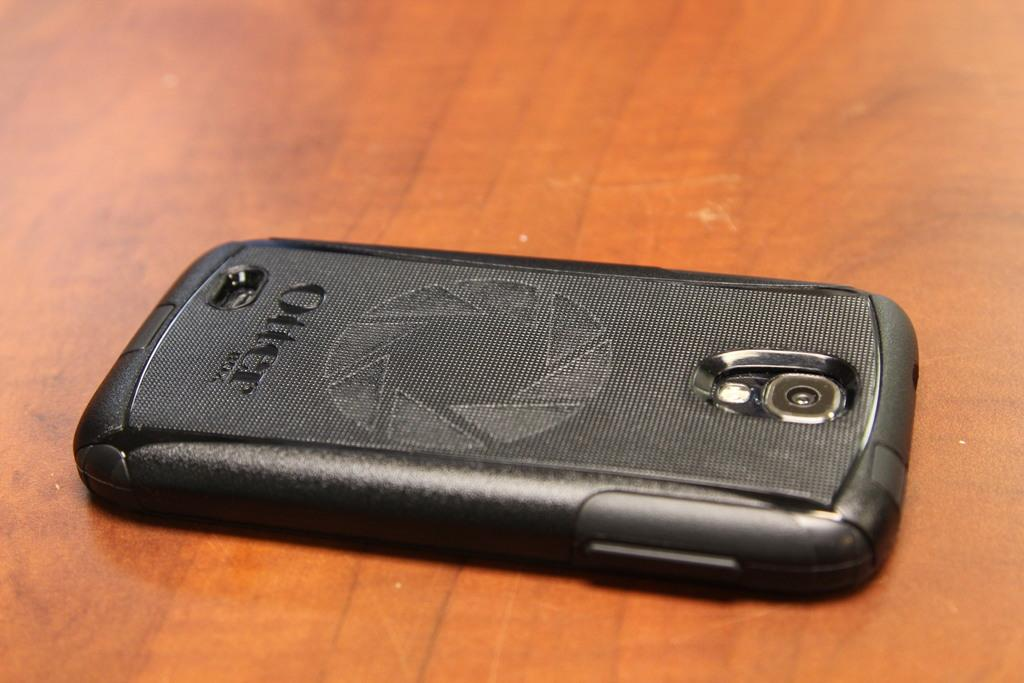What electronic device is visible in the image? There is a mobile phone in the image. What type of surface is the mobile phone placed on? The mobile phone is on a wooden surface. Can you hear the songs being played by the line in the image? There is no line or songs present in the image; it only features a mobile phone on a wooden surface. 